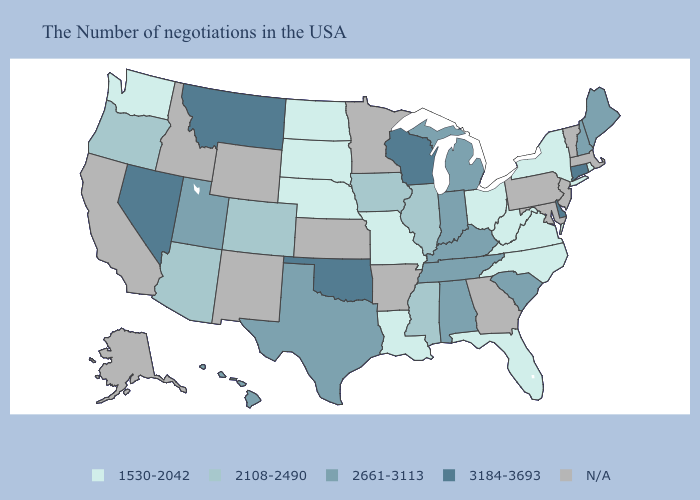Name the states that have a value in the range N/A?
Short answer required. Massachusetts, Vermont, New Jersey, Maryland, Pennsylvania, Georgia, Arkansas, Minnesota, Kansas, Wyoming, New Mexico, Idaho, California, Alaska. Name the states that have a value in the range N/A?
Keep it brief. Massachusetts, Vermont, New Jersey, Maryland, Pennsylvania, Georgia, Arkansas, Minnesota, Kansas, Wyoming, New Mexico, Idaho, California, Alaska. What is the lowest value in the Northeast?
Write a very short answer. 1530-2042. Among the states that border Arizona , which have the lowest value?
Give a very brief answer. Colorado. Does Wisconsin have the highest value in the MidWest?
Write a very short answer. Yes. What is the value of Oklahoma?
Give a very brief answer. 3184-3693. Name the states that have a value in the range N/A?
Be succinct. Massachusetts, Vermont, New Jersey, Maryland, Pennsylvania, Georgia, Arkansas, Minnesota, Kansas, Wyoming, New Mexico, Idaho, California, Alaska. What is the value of Iowa?
Concise answer only. 2108-2490. What is the highest value in the Northeast ?
Quick response, please. 3184-3693. What is the value of Idaho?
Keep it brief. N/A. Name the states that have a value in the range 3184-3693?
Give a very brief answer. Connecticut, Delaware, Wisconsin, Oklahoma, Montana, Nevada. Which states hav the highest value in the Northeast?
Short answer required. Connecticut. Name the states that have a value in the range 2108-2490?
Quick response, please. Illinois, Mississippi, Iowa, Colorado, Arizona, Oregon. 